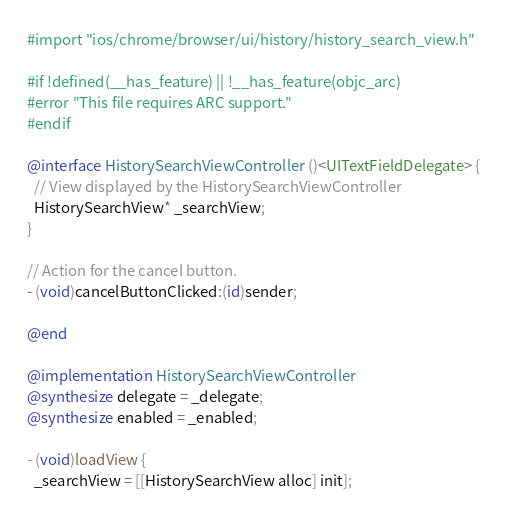<code> <loc_0><loc_0><loc_500><loc_500><_ObjectiveC_>#import "ios/chrome/browser/ui/history/history_search_view.h"

#if !defined(__has_feature) || !__has_feature(objc_arc)
#error "This file requires ARC support."
#endif

@interface HistorySearchViewController ()<UITextFieldDelegate> {
  // View displayed by the HistorySearchViewController
  HistorySearchView* _searchView;
}

// Action for the cancel button.
- (void)cancelButtonClicked:(id)sender;

@end

@implementation HistorySearchViewController
@synthesize delegate = _delegate;
@synthesize enabled = _enabled;

- (void)loadView {
  _searchView = [[HistorySearchView alloc] init];</code> 